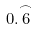Convert formula to latex. <formula><loc_0><loc_0><loc_500><loc_500>0 . { \overset { \frown } { 6 } }</formula> 